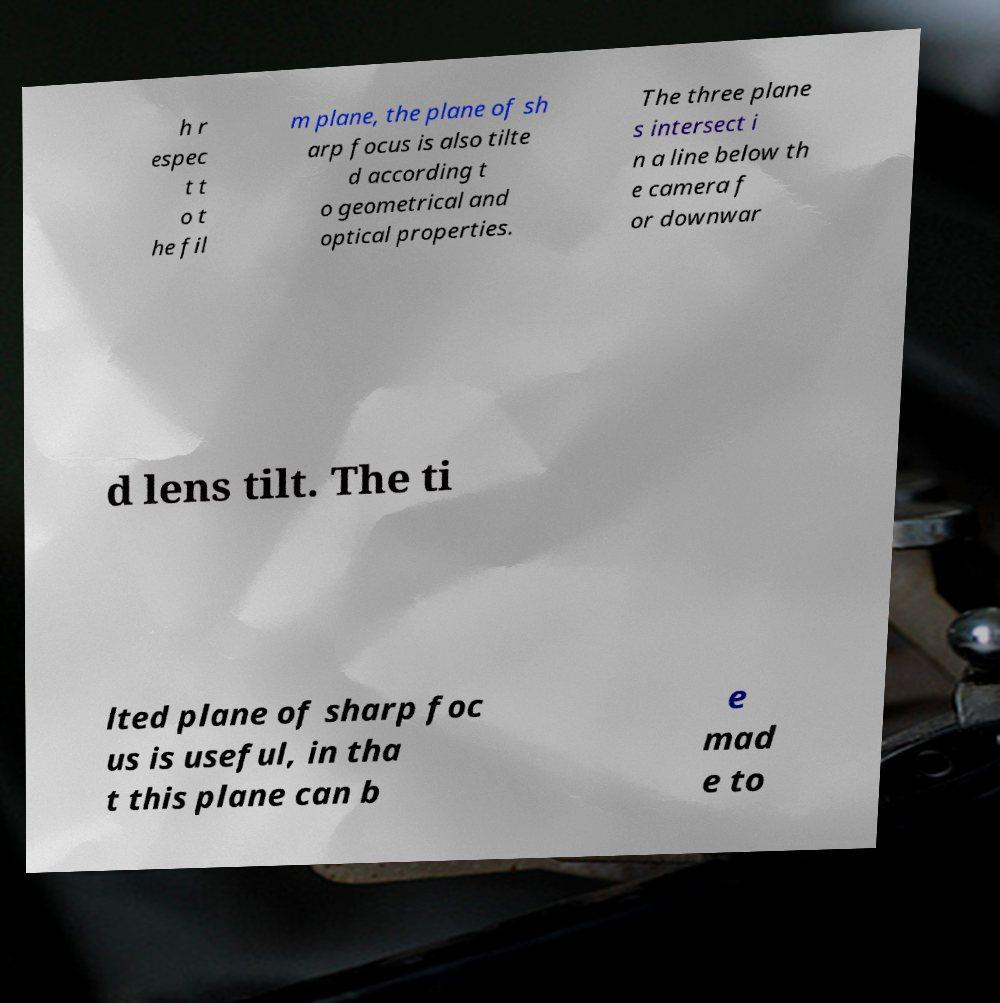Could you assist in decoding the text presented in this image and type it out clearly? h r espec t t o t he fil m plane, the plane of sh arp focus is also tilte d according t o geometrical and optical properties. The three plane s intersect i n a line below th e camera f or downwar d lens tilt. The ti lted plane of sharp foc us is useful, in tha t this plane can b e mad e to 